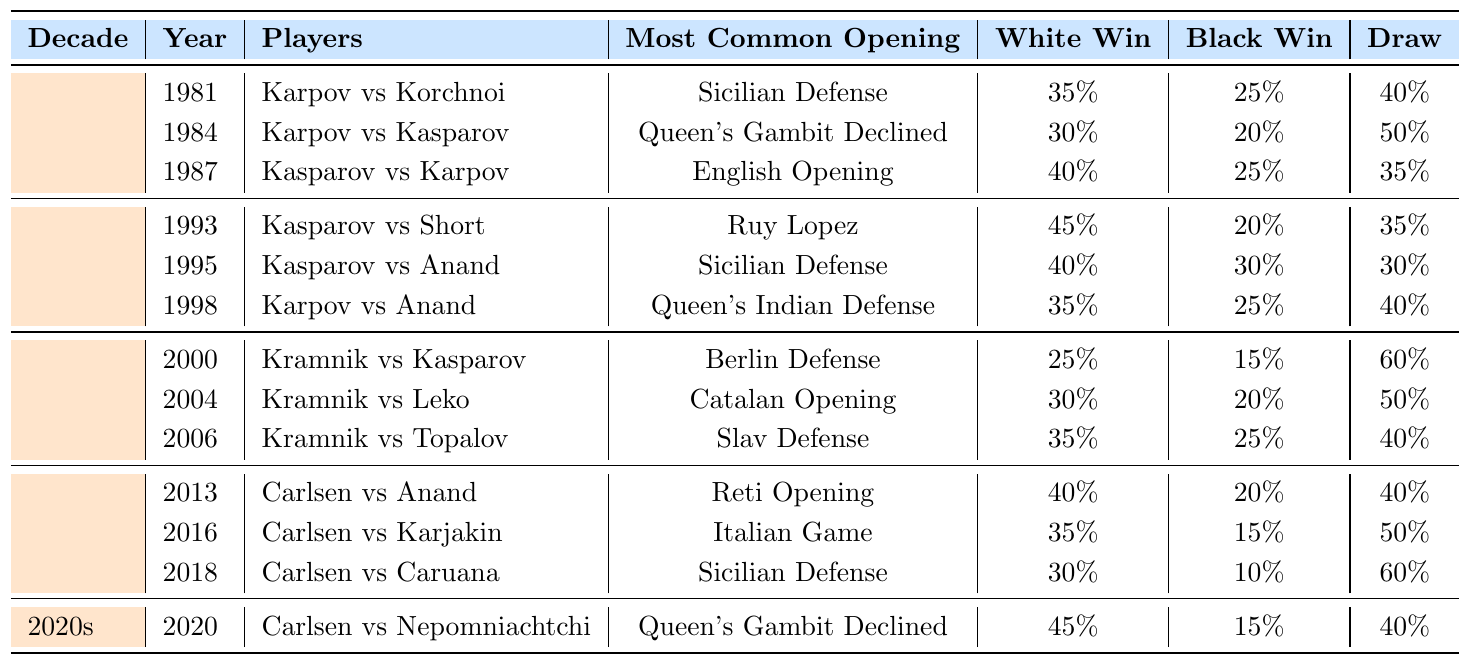What was the most common opening used in the 1987 World Championship match? In the 1987 match between Garry Kasparov and Anatoly Karpov, the most common opening listed in the table is the English Opening.
Answer: English Opening How many matches ended in a draw in the 1995 World Championship match? The 1995 match between Garry Kasparov and Viswanathan Anand had a draw rate of 30%, meaning that 30% of the games played were draws.
Answer: 30% Which decade had the highest White win rate in matches listed? In the 1990s, the highest White win rate from the data is found in the 1993 match with a win rate of 45%, the only higher percentage than the 40% found in the 2010s and 2020s.
Answer: 1990s How many matches featured the Sicilian Defense as the most common opening from 1980 to 2020? The Sicilian Defense was the most common opening in three matches: 1981, 1995, and 2018.
Answer: 3 What is the average draw rate for matches in the 2000s? The draw rates in the 2000s matches are 60%, 50%, and 40%. Summing these gives 150%, and dividing by the three matches gives an average draw rate of 50%.
Answer: 50% Did any match in the 2010s have a Black win rate higher than 20%? Yes, the 2015 match between Magnus Carlsen and Sergey Karjakin had a Black win rate of 15%, which is lower than 20%. However, the 2013 match featured a 20% Black win rate. All other matches rounded up to this are also below.
Answer: No Which match had the lowest White win rate, and what was that rate? The match between Vladimir Kramnik and Garry Kasparov in the year 2000 had the lowest White win rate of 25%.
Answer: 25% In the 2020s, what was the Black win rate in the championship match? The match in the year 2020 featured a Black win rate of 15%.
Answer: 15% Which decade had the most matches listed in the table? Each decade has only three matches listed except for the 2020s, which only has one, making the 1980s, 1990s, and 2000s tied in number of matches.
Answer: No decade is higher What was the total number of matches that featured the Queen's Gambit Declined as the most common opening? The openings listed in the table with Queen's Gambit Declined appeared in 1984 and 2020, thus appearing in two matches.
Answer: 2 